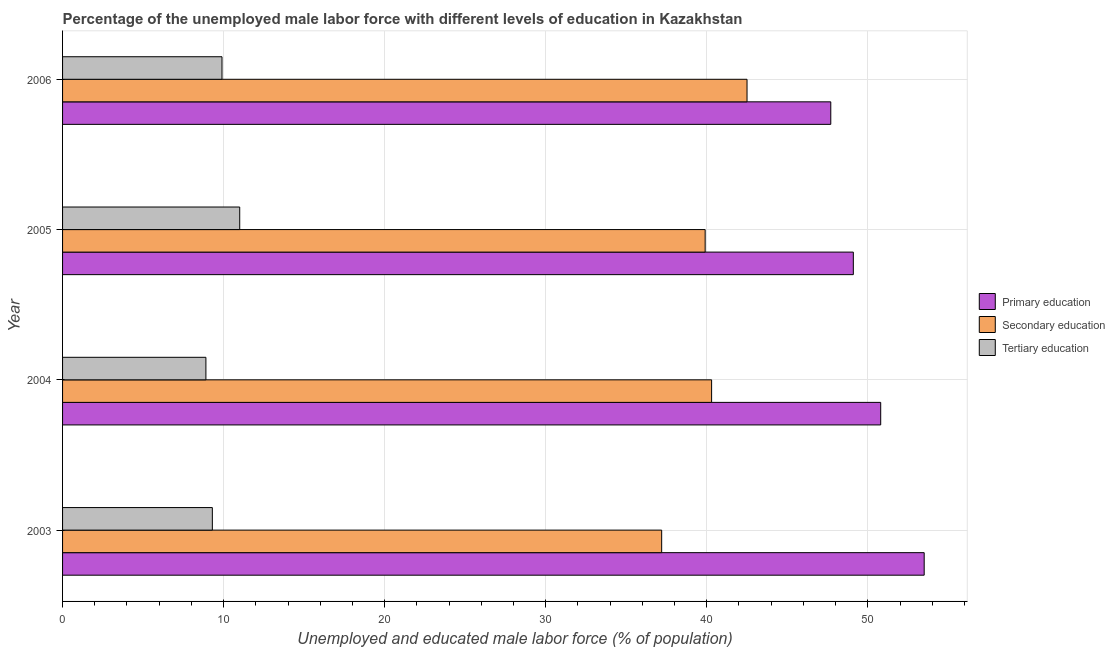How many different coloured bars are there?
Provide a short and direct response. 3. Are the number of bars on each tick of the Y-axis equal?
Provide a short and direct response. Yes. What is the percentage of male labor force who received secondary education in 2005?
Ensure brevity in your answer.  39.9. Across all years, what is the maximum percentage of male labor force who received primary education?
Keep it short and to the point. 53.5. Across all years, what is the minimum percentage of male labor force who received secondary education?
Your answer should be compact. 37.2. In which year was the percentage of male labor force who received tertiary education maximum?
Ensure brevity in your answer.  2005. In which year was the percentage of male labor force who received primary education minimum?
Your answer should be compact. 2006. What is the total percentage of male labor force who received tertiary education in the graph?
Make the answer very short. 39.1. What is the difference between the percentage of male labor force who received secondary education in 2003 and the percentage of male labor force who received primary education in 2004?
Your answer should be compact. -13.6. What is the average percentage of male labor force who received primary education per year?
Keep it short and to the point. 50.27. In the year 2006, what is the difference between the percentage of male labor force who received tertiary education and percentage of male labor force who received secondary education?
Keep it short and to the point. -32.6. In how many years, is the percentage of male labor force who received tertiary education greater than 38 %?
Give a very brief answer. 0. What is the ratio of the percentage of male labor force who received primary education in 2003 to that in 2004?
Ensure brevity in your answer.  1.05. Is the percentage of male labor force who received secondary education in 2004 less than that in 2005?
Offer a terse response. No. Is the difference between the percentage of male labor force who received primary education in 2004 and 2005 greater than the difference between the percentage of male labor force who received tertiary education in 2004 and 2005?
Your answer should be compact. Yes. Is the sum of the percentage of male labor force who received secondary education in 2003 and 2006 greater than the maximum percentage of male labor force who received tertiary education across all years?
Make the answer very short. Yes. What does the 2nd bar from the top in 2004 represents?
Provide a short and direct response. Secondary education. What does the 3rd bar from the bottom in 2005 represents?
Keep it short and to the point. Tertiary education. Does the graph contain any zero values?
Your answer should be compact. No. Does the graph contain grids?
Offer a very short reply. Yes. What is the title of the graph?
Offer a terse response. Percentage of the unemployed male labor force with different levels of education in Kazakhstan. Does "Agricultural raw materials" appear as one of the legend labels in the graph?
Your response must be concise. No. What is the label or title of the X-axis?
Provide a short and direct response. Unemployed and educated male labor force (% of population). What is the label or title of the Y-axis?
Provide a succinct answer. Year. What is the Unemployed and educated male labor force (% of population) of Primary education in 2003?
Your response must be concise. 53.5. What is the Unemployed and educated male labor force (% of population) in Secondary education in 2003?
Your response must be concise. 37.2. What is the Unemployed and educated male labor force (% of population) in Tertiary education in 2003?
Provide a succinct answer. 9.3. What is the Unemployed and educated male labor force (% of population) of Primary education in 2004?
Keep it short and to the point. 50.8. What is the Unemployed and educated male labor force (% of population) in Secondary education in 2004?
Your answer should be very brief. 40.3. What is the Unemployed and educated male labor force (% of population) of Tertiary education in 2004?
Your answer should be compact. 8.9. What is the Unemployed and educated male labor force (% of population) in Primary education in 2005?
Make the answer very short. 49.1. What is the Unemployed and educated male labor force (% of population) in Secondary education in 2005?
Your answer should be very brief. 39.9. What is the Unemployed and educated male labor force (% of population) in Tertiary education in 2005?
Ensure brevity in your answer.  11. What is the Unemployed and educated male labor force (% of population) in Primary education in 2006?
Offer a terse response. 47.7. What is the Unemployed and educated male labor force (% of population) of Secondary education in 2006?
Give a very brief answer. 42.5. What is the Unemployed and educated male labor force (% of population) of Tertiary education in 2006?
Provide a succinct answer. 9.9. Across all years, what is the maximum Unemployed and educated male labor force (% of population) of Primary education?
Make the answer very short. 53.5. Across all years, what is the maximum Unemployed and educated male labor force (% of population) of Secondary education?
Give a very brief answer. 42.5. Across all years, what is the maximum Unemployed and educated male labor force (% of population) of Tertiary education?
Your response must be concise. 11. Across all years, what is the minimum Unemployed and educated male labor force (% of population) in Primary education?
Keep it short and to the point. 47.7. Across all years, what is the minimum Unemployed and educated male labor force (% of population) in Secondary education?
Offer a terse response. 37.2. Across all years, what is the minimum Unemployed and educated male labor force (% of population) of Tertiary education?
Provide a succinct answer. 8.9. What is the total Unemployed and educated male labor force (% of population) of Primary education in the graph?
Your response must be concise. 201.1. What is the total Unemployed and educated male labor force (% of population) of Secondary education in the graph?
Keep it short and to the point. 159.9. What is the total Unemployed and educated male labor force (% of population) in Tertiary education in the graph?
Your answer should be very brief. 39.1. What is the difference between the Unemployed and educated male labor force (% of population) in Tertiary education in 2003 and that in 2004?
Your answer should be very brief. 0.4. What is the difference between the Unemployed and educated male labor force (% of population) in Secondary education in 2003 and that in 2005?
Offer a very short reply. -2.7. What is the difference between the Unemployed and educated male labor force (% of population) in Tertiary education in 2003 and that in 2006?
Your answer should be compact. -0.6. What is the difference between the Unemployed and educated male labor force (% of population) in Primary education in 2004 and that in 2005?
Make the answer very short. 1.7. What is the difference between the Unemployed and educated male labor force (% of population) in Secondary education in 2004 and that in 2005?
Your answer should be compact. 0.4. What is the difference between the Unemployed and educated male labor force (% of population) of Secondary education in 2004 and that in 2006?
Give a very brief answer. -2.2. What is the difference between the Unemployed and educated male labor force (% of population) in Primary education in 2003 and the Unemployed and educated male labor force (% of population) in Tertiary education in 2004?
Your answer should be very brief. 44.6. What is the difference between the Unemployed and educated male labor force (% of population) of Secondary education in 2003 and the Unemployed and educated male labor force (% of population) of Tertiary education in 2004?
Keep it short and to the point. 28.3. What is the difference between the Unemployed and educated male labor force (% of population) of Primary education in 2003 and the Unemployed and educated male labor force (% of population) of Tertiary education in 2005?
Make the answer very short. 42.5. What is the difference between the Unemployed and educated male labor force (% of population) in Secondary education in 2003 and the Unemployed and educated male labor force (% of population) in Tertiary education in 2005?
Ensure brevity in your answer.  26.2. What is the difference between the Unemployed and educated male labor force (% of population) of Primary education in 2003 and the Unemployed and educated male labor force (% of population) of Tertiary education in 2006?
Your answer should be very brief. 43.6. What is the difference between the Unemployed and educated male labor force (% of population) in Secondary education in 2003 and the Unemployed and educated male labor force (% of population) in Tertiary education in 2006?
Ensure brevity in your answer.  27.3. What is the difference between the Unemployed and educated male labor force (% of population) in Primary education in 2004 and the Unemployed and educated male labor force (% of population) in Secondary education in 2005?
Provide a short and direct response. 10.9. What is the difference between the Unemployed and educated male labor force (% of population) in Primary education in 2004 and the Unemployed and educated male labor force (% of population) in Tertiary education in 2005?
Ensure brevity in your answer.  39.8. What is the difference between the Unemployed and educated male labor force (% of population) in Secondary education in 2004 and the Unemployed and educated male labor force (% of population) in Tertiary education in 2005?
Give a very brief answer. 29.3. What is the difference between the Unemployed and educated male labor force (% of population) in Primary education in 2004 and the Unemployed and educated male labor force (% of population) in Secondary education in 2006?
Your answer should be compact. 8.3. What is the difference between the Unemployed and educated male labor force (% of population) of Primary education in 2004 and the Unemployed and educated male labor force (% of population) of Tertiary education in 2006?
Give a very brief answer. 40.9. What is the difference between the Unemployed and educated male labor force (% of population) in Secondary education in 2004 and the Unemployed and educated male labor force (% of population) in Tertiary education in 2006?
Give a very brief answer. 30.4. What is the difference between the Unemployed and educated male labor force (% of population) in Primary education in 2005 and the Unemployed and educated male labor force (% of population) in Secondary education in 2006?
Make the answer very short. 6.6. What is the difference between the Unemployed and educated male labor force (% of population) of Primary education in 2005 and the Unemployed and educated male labor force (% of population) of Tertiary education in 2006?
Offer a very short reply. 39.2. What is the difference between the Unemployed and educated male labor force (% of population) in Secondary education in 2005 and the Unemployed and educated male labor force (% of population) in Tertiary education in 2006?
Provide a short and direct response. 30. What is the average Unemployed and educated male labor force (% of population) in Primary education per year?
Keep it short and to the point. 50.27. What is the average Unemployed and educated male labor force (% of population) in Secondary education per year?
Keep it short and to the point. 39.98. What is the average Unemployed and educated male labor force (% of population) in Tertiary education per year?
Offer a terse response. 9.78. In the year 2003, what is the difference between the Unemployed and educated male labor force (% of population) of Primary education and Unemployed and educated male labor force (% of population) of Secondary education?
Provide a succinct answer. 16.3. In the year 2003, what is the difference between the Unemployed and educated male labor force (% of population) of Primary education and Unemployed and educated male labor force (% of population) of Tertiary education?
Your answer should be very brief. 44.2. In the year 2003, what is the difference between the Unemployed and educated male labor force (% of population) of Secondary education and Unemployed and educated male labor force (% of population) of Tertiary education?
Give a very brief answer. 27.9. In the year 2004, what is the difference between the Unemployed and educated male labor force (% of population) in Primary education and Unemployed and educated male labor force (% of population) in Secondary education?
Your answer should be very brief. 10.5. In the year 2004, what is the difference between the Unemployed and educated male labor force (% of population) in Primary education and Unemployed and educated male labor force (% of population) in Tertiary education?
Your answer should be compact. 41.9. In the year 2004, what is the difference between the Unemployed and educated male labor force (% of population) in Secondary education and Unemployed and educated male labor force (% of population) in Tertiary education?
Your answer should be very brief. 31.4. In the year 2005, what is the difference between the Unemployed and educated male labor force (% of population) in Primary education and Unemployed and educated male labor force (% of population) in Secondary education?
Your response must be concise. 9.2. In the year 2005, what is the difference between the Unemployed and educated male labor force (% of population) of Primary education and Unemployed and educated male labor force (% of population) of Tertiary education?
Offer a very short reply. 38.1. In the year 2005, what is the difference between the Unemployed and educated male labor force (% of population) in Secondary education and Unemployed and educated male labor force (% of population) in Tertiary education?
Offer a terse response. 28.9. In the year 2006, what is the difference between the Unemployed and educated male labor force (% of population) of Primary education and Unemployed and educated male labor force (% of population) of Tertiary education?
Give a very brief answer. 37.8. In the year 2006, what is the difference between the Unemployed and educated male labor force (% of population) in Secondary education and Unemployed and educated male labor force (% of population) in Tertiary education?
Give a very brief answer. 32.6. What is the ratio of the Unemployed and educated male labor force (% of population) of Primary education in 2003 to that in 2004?
Ensure brevity in your answer.  1.05. What is the ratio of the Unemployed and educated male labor force (% of population) of Secondary education in 2003 to that in 2004?
Provide a succinct answer. 0.92. What is the ratio of the Unemployed and educated male labor force (% of population) in Tertiary education in 2003 to that in 2004?
Your answer should be very brief. 1.04. What is the ratio of the Unemployed and educated male labor force (% of population) in Primary education in 2003 to that in 2005?
Provide a short and direct response. 1.09. What is the ratio of the Unemployed and educated male labor force (% of population) of Secondary education in 2003 to that in 2005?
Your response must be concise. 0.93. What is the ratio of the Unemployed and educated male labor force (% of population) of Tertiary education in 2003 to that in 2005?
Provide a short and direct response. 0.85. What is the ratio of the Unemployed and educated male labor force (% of population) of Primary education in 2003 to that in 2006?
Ensure brevity in your answer.  1.12. What is the ratio of the Unemployed and educated male labor force (% of population) of Secondary education in 2003 to that in 2006?
Give a very brief answer. 0.88. What is the ratio of the Unemployed and educated male labor force (% of population) of Tertiary education in 2003 to that in 2006?
Offer a very short reply. 0.94. What is the ratio of the Unemployed and educated male labor force (% of population) in Primary education in 2004 to that in 2005?
Your response must be concise. 1.03. What is the ratio of the Unemployed and educated male labor force (% of population) in Tertiary education in 2004 to that in 2005?
Provide a succinct answer. 0.81. What is the ratio of the Unemployed and educated male labor force (% of population) in Primary education in 2004 to that in 2006?
Keep it short and to the point. 1.06. What is the ratio of the Unemployed and educated male labor force (% of population) in Secondary education in 2004 to that in 2006?
Give a very brief answer. 0.95. What is the ratio of the Unemployed and educated male labor force (% of population) in Tertiary education in 2004 to that in 2006?
Offer a terse response. 0.9. What is the ratio of the Unemployed and educated male labor force (% of population) in Primary education in 2005 to that in 2006?
Give a very brief answer. 1.03. What is the ratio of the Unemployed and educated male labor force (% of population) of Secondary education in 2005 to that in 2006?
Your answer should be compact. 0.94. What is the ratio of the Unemployed and educated male labor force (% of population) in Tertiary education in 2005 to that in 2006?
Offer a very short reply. 1.11. What is the difference between the highest and the second highest Unemployed and educated male labor force (% of population) of Primary education?
Provide a short and direct response. 2.7. What is the difference between the highest and the second highest Unemployed and educated male labor force (% of population) of Tertiary education?
Keep it short and to the point. 1.1. What is the difference between the highest and the lowest Unemployed and educated male labor force (% of population) in Primary education?
Provide a short and direct response. 5.8. What is the difference between the highest and the lowest Unemployed and educated male labor force (% of population) of Tertiary education?
Keep it short and to the point. 2.1. 